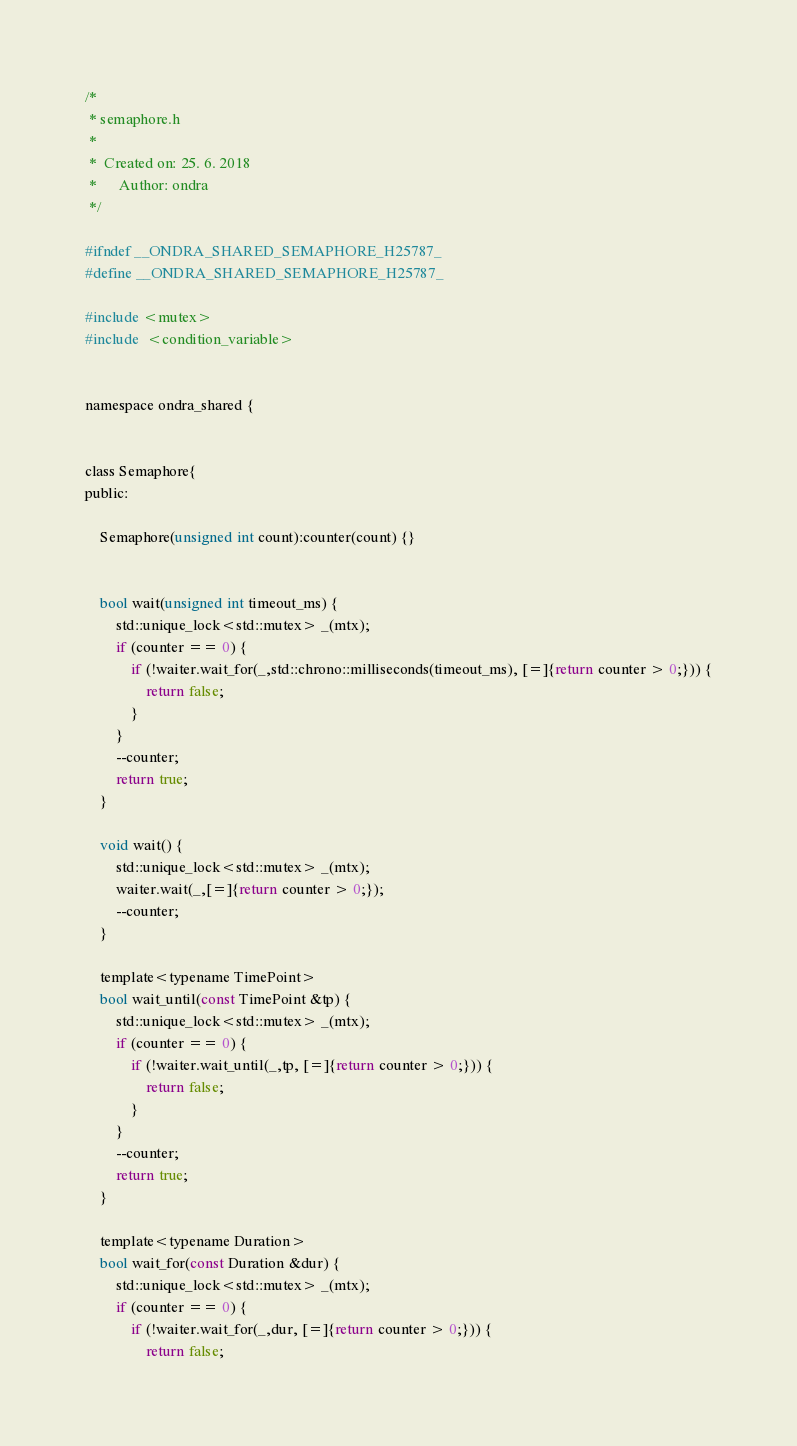Convert code to text. <code><loc_0><loc_0><loc_500><loc_500><_C_>/*
 * semaphore.h
 *
 *  Created on: 25. 6. 2018
 *      Author: ondra
 */

#ifndef __ONDRA_SHARED_SEMAPHORE_H25787_
#define __ONDRA_SHARED_SEMAPHORE_H25787_

#include <mutex>
#include  <condition_variable>


namespace ondra_shared {


class Semaphore{
public:

	Semaphore(unsigned int count):counter(count) {}


	bool wait(unsigned int timeout_ms) {
		std::unique_lock<std::mutex> _(mtx);
		if (counter == 0) {
			if (!waiter.wait_for(_,std::chrono::milliseconds(timeout_ms), [=]{return counter > 0;})) {
				return false;
			}
		}
		--counter;
		return true;
	}

	void wait() {
		std::unique_lock<std::mutex> _(mtx);
		waiter.wait(_,[=]{return counter > 0;});
		--counter;
	}

	template<typename TimePoint>
	bool wait_until(const TimePoint &tp) {
		std::unique_lock<std::mutex> _(mtx);
		if (counter == 0) {
			if (!waiter.wait_until(_,tp, [=]{return counter > 0;})) {
				return false;
			}
		}
		--counter;
		return true;
	}

	template<typename Duration>
	bool wait_for(const Duration &dur) {
		std::unique_lock<std::mutex> _(mtx);
		if (counter == 0) {
			if (!waiter.wait_for(_,dur, [=]{return counter > 0;})) {
				return false;</code> 